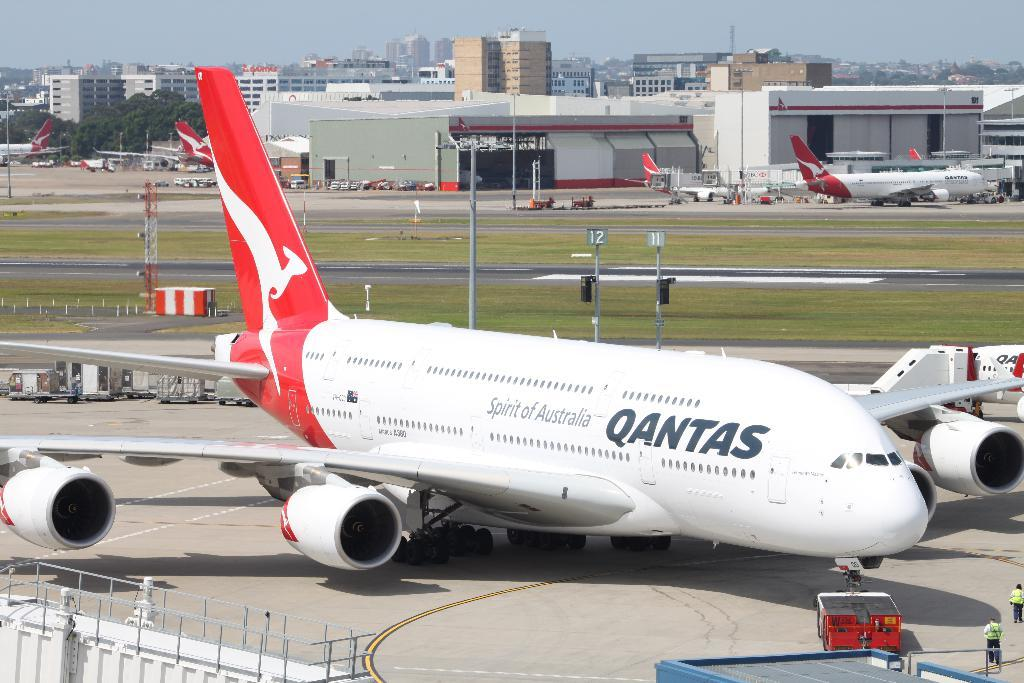<image>
Give a short and clear explanation of the subsequent image. a Qantas airplane on a runway is waiting to be maintained 